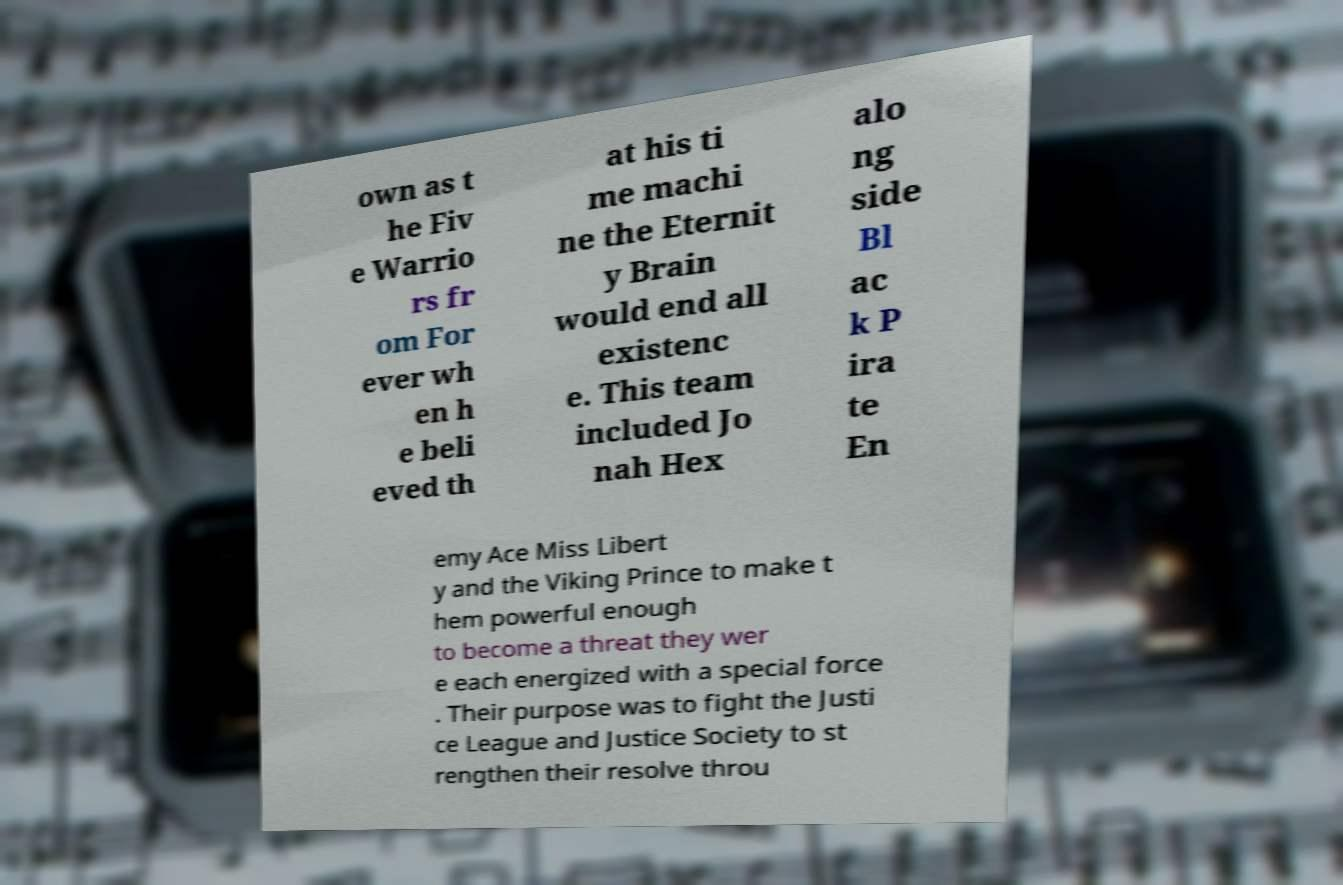Can you accurately transcribe the text from the provided image for me? own as t he Fiv e Warrio rs fr om For ever wh en h e beli eved th at his ti me machi ne the Eternit y Brain would end all existenc e. This team included Jo nah Hex alo ng side Bl ac k P ira te En emy Ace Miss Libert y and the Viking Prince to make t hem powerful enough to become a threat they wer e each energized with a special force . Their purpose was to fight the Justi ce League and Justice Society to st rengthen their resolve throu 